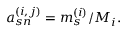<formula> <loc_0><loc_0><loc_500><loc_500>a _ { s n } ^ { ( i , j ) } = m _ { s } ^ { ( i ) } / M _ { i } .</formula> 